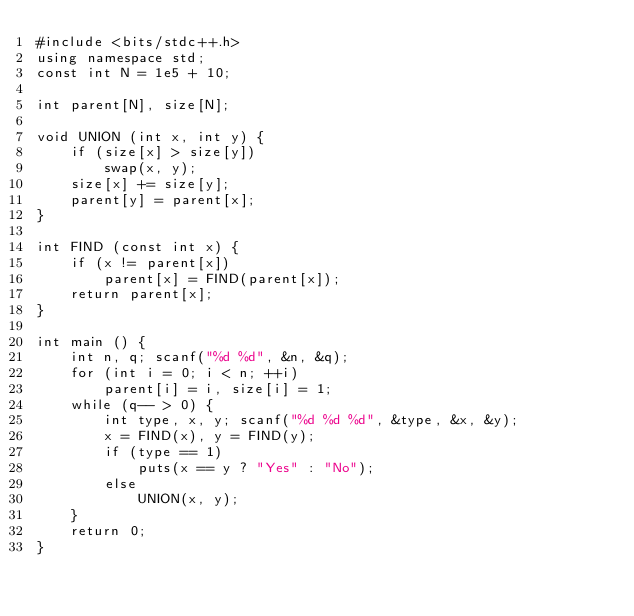<code> <loc_0><loc_0><loc_500><loc_500><_C++_>#include <bits/stdc++.h>
using namespace std;
const int N = 1e5 + 10;

int parent[N], size[N];

void UNION (int x, int y) {
    if (size[x] > size[y])
        swap(x, y);
    size[x] += size[y];
    parent[y] = parent[x];
}

int FIND (const int x) {
    if (x != parent[x])
        parent[x] = FIND(parent[x]);
    return parent[x];
}

int main () {
    int n, q; scanf("%d %d", &n, &q);
    for (int i = 0; i < n; ++i)
        parent[i] = i, size[i] = 1;
    while (q-- > 0) {
        int type, x, y; scanf("%d %d %d", &type, &x, &y);
        x = FIND(x), y = FIND(y);
        if (type == 1)
            puts(x == y ? "Yes" : "No");
        else
            UNION(x, y);
    }
    return 0;
}</code> 